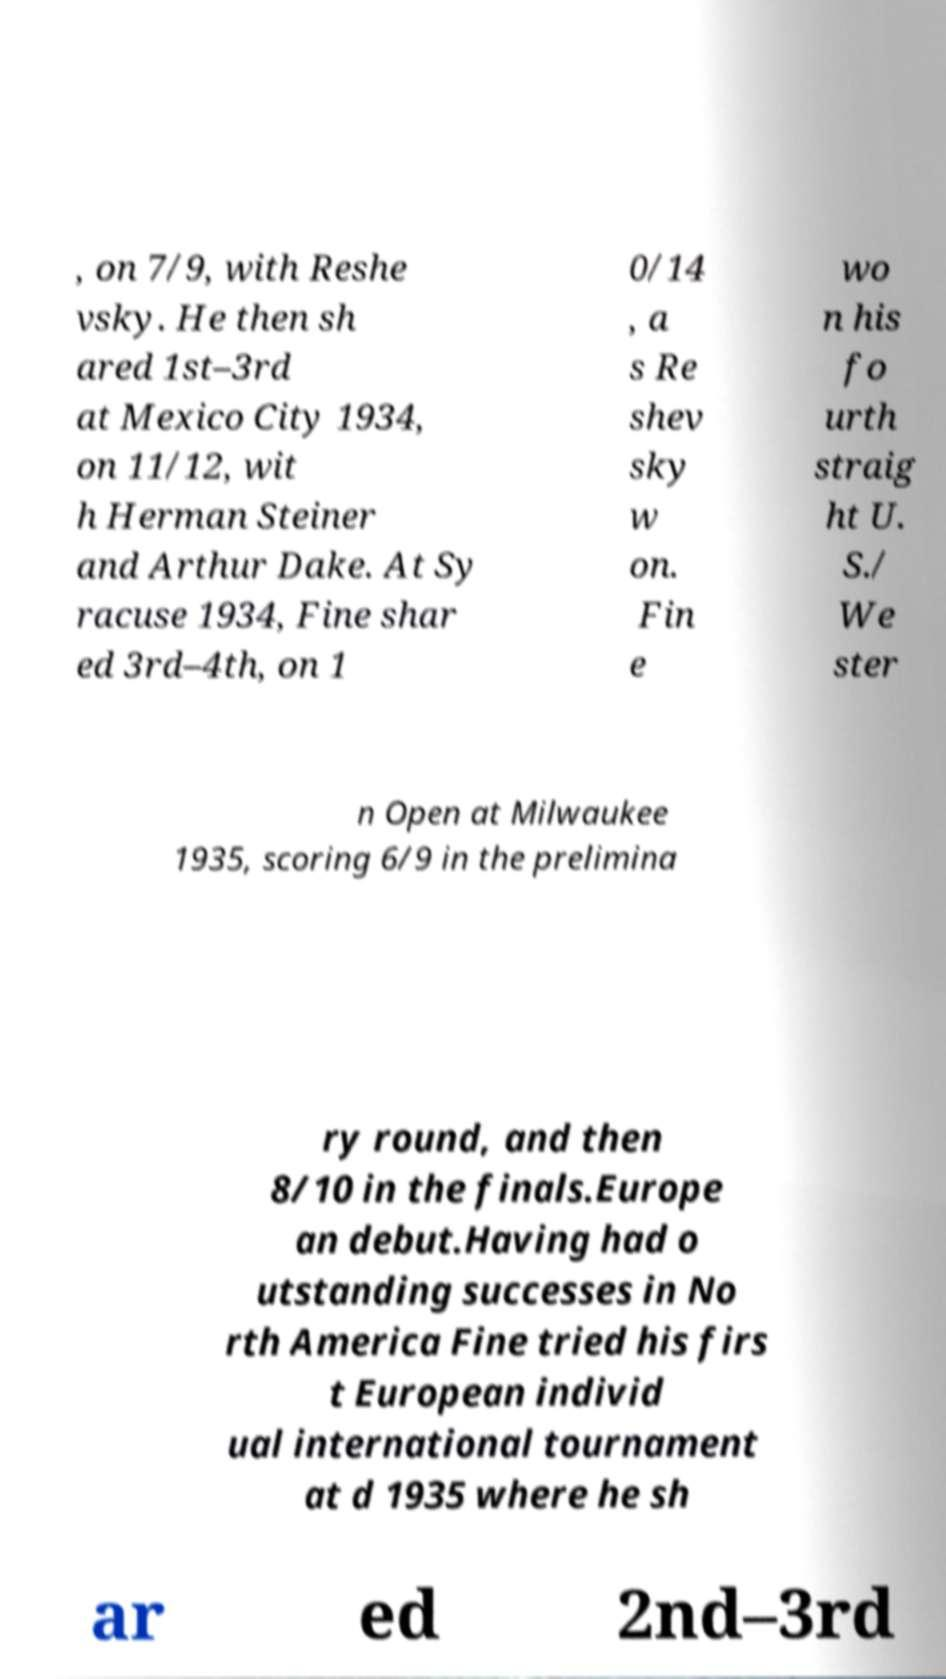There's text embedded in this image that I need extracted. Can you transcribe it verbatim? , on 7/9, with Reshe vsky. He then sh ared 1st–3rd at Mexico City 1934, on 11/12, wit h Herman Steiner and Arthur Dake. At Sy racuse 1934, Fine shar ed 3rd–4th, on 1 0/14 , a s Re shev sky w on. Fin e wo n his fo urth straig ht U. S./ We ster n Open at Milwaukee 1935, scoring 6/9 in the prelimina ry round, and then 8/10 in the finals.Europe an debut.Having had o utstanding successes in No rth America Fine tried his firs t European individ ual international tournament at d 1935 where he sh ar ed 2nd–3rd 